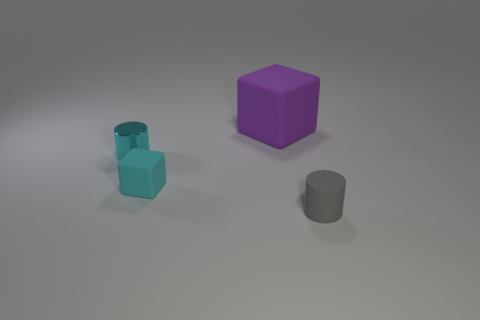What could be the relative sizes of these objects? Based on the perspective shown in the image, the teal cylinder appears to be the smallest object. The gray cylinder seems to be slightly larger, but not as large as the purple cube, which stands out as the largest object of the three. Is there any indication of these objects being used for anything, or do they appear purely for demonstration? The objects seem to be placed for demonstration purposes. There's no apparent context or environment that suggests a specific use. They could likely be used for reference in a discussion about geometry, colors, or for a visual composition exercise. 